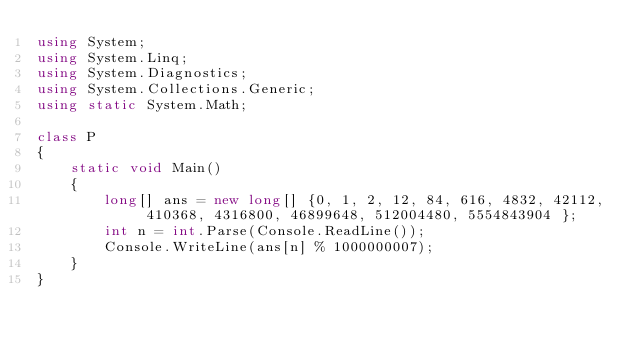<code> <loc_0><loc_0><loc_500><loc_500><_C#_>using System;
using System.Linq;
using System.Diagnostics;
using System.Collections.Generic;
using static System.Math;
 
class P
{
    static void Main()
    {
        long[] ans = new long[] {0, 1, 2, 12, 84, 616, 4832, 42112, 410368, 4316800, 46899648, 512004480, 5554843904 };
        int n = int.Parse(Console.ReadLine());
        Console.WriteLine(ans[n] % 1000000007);
    }
}</code> 